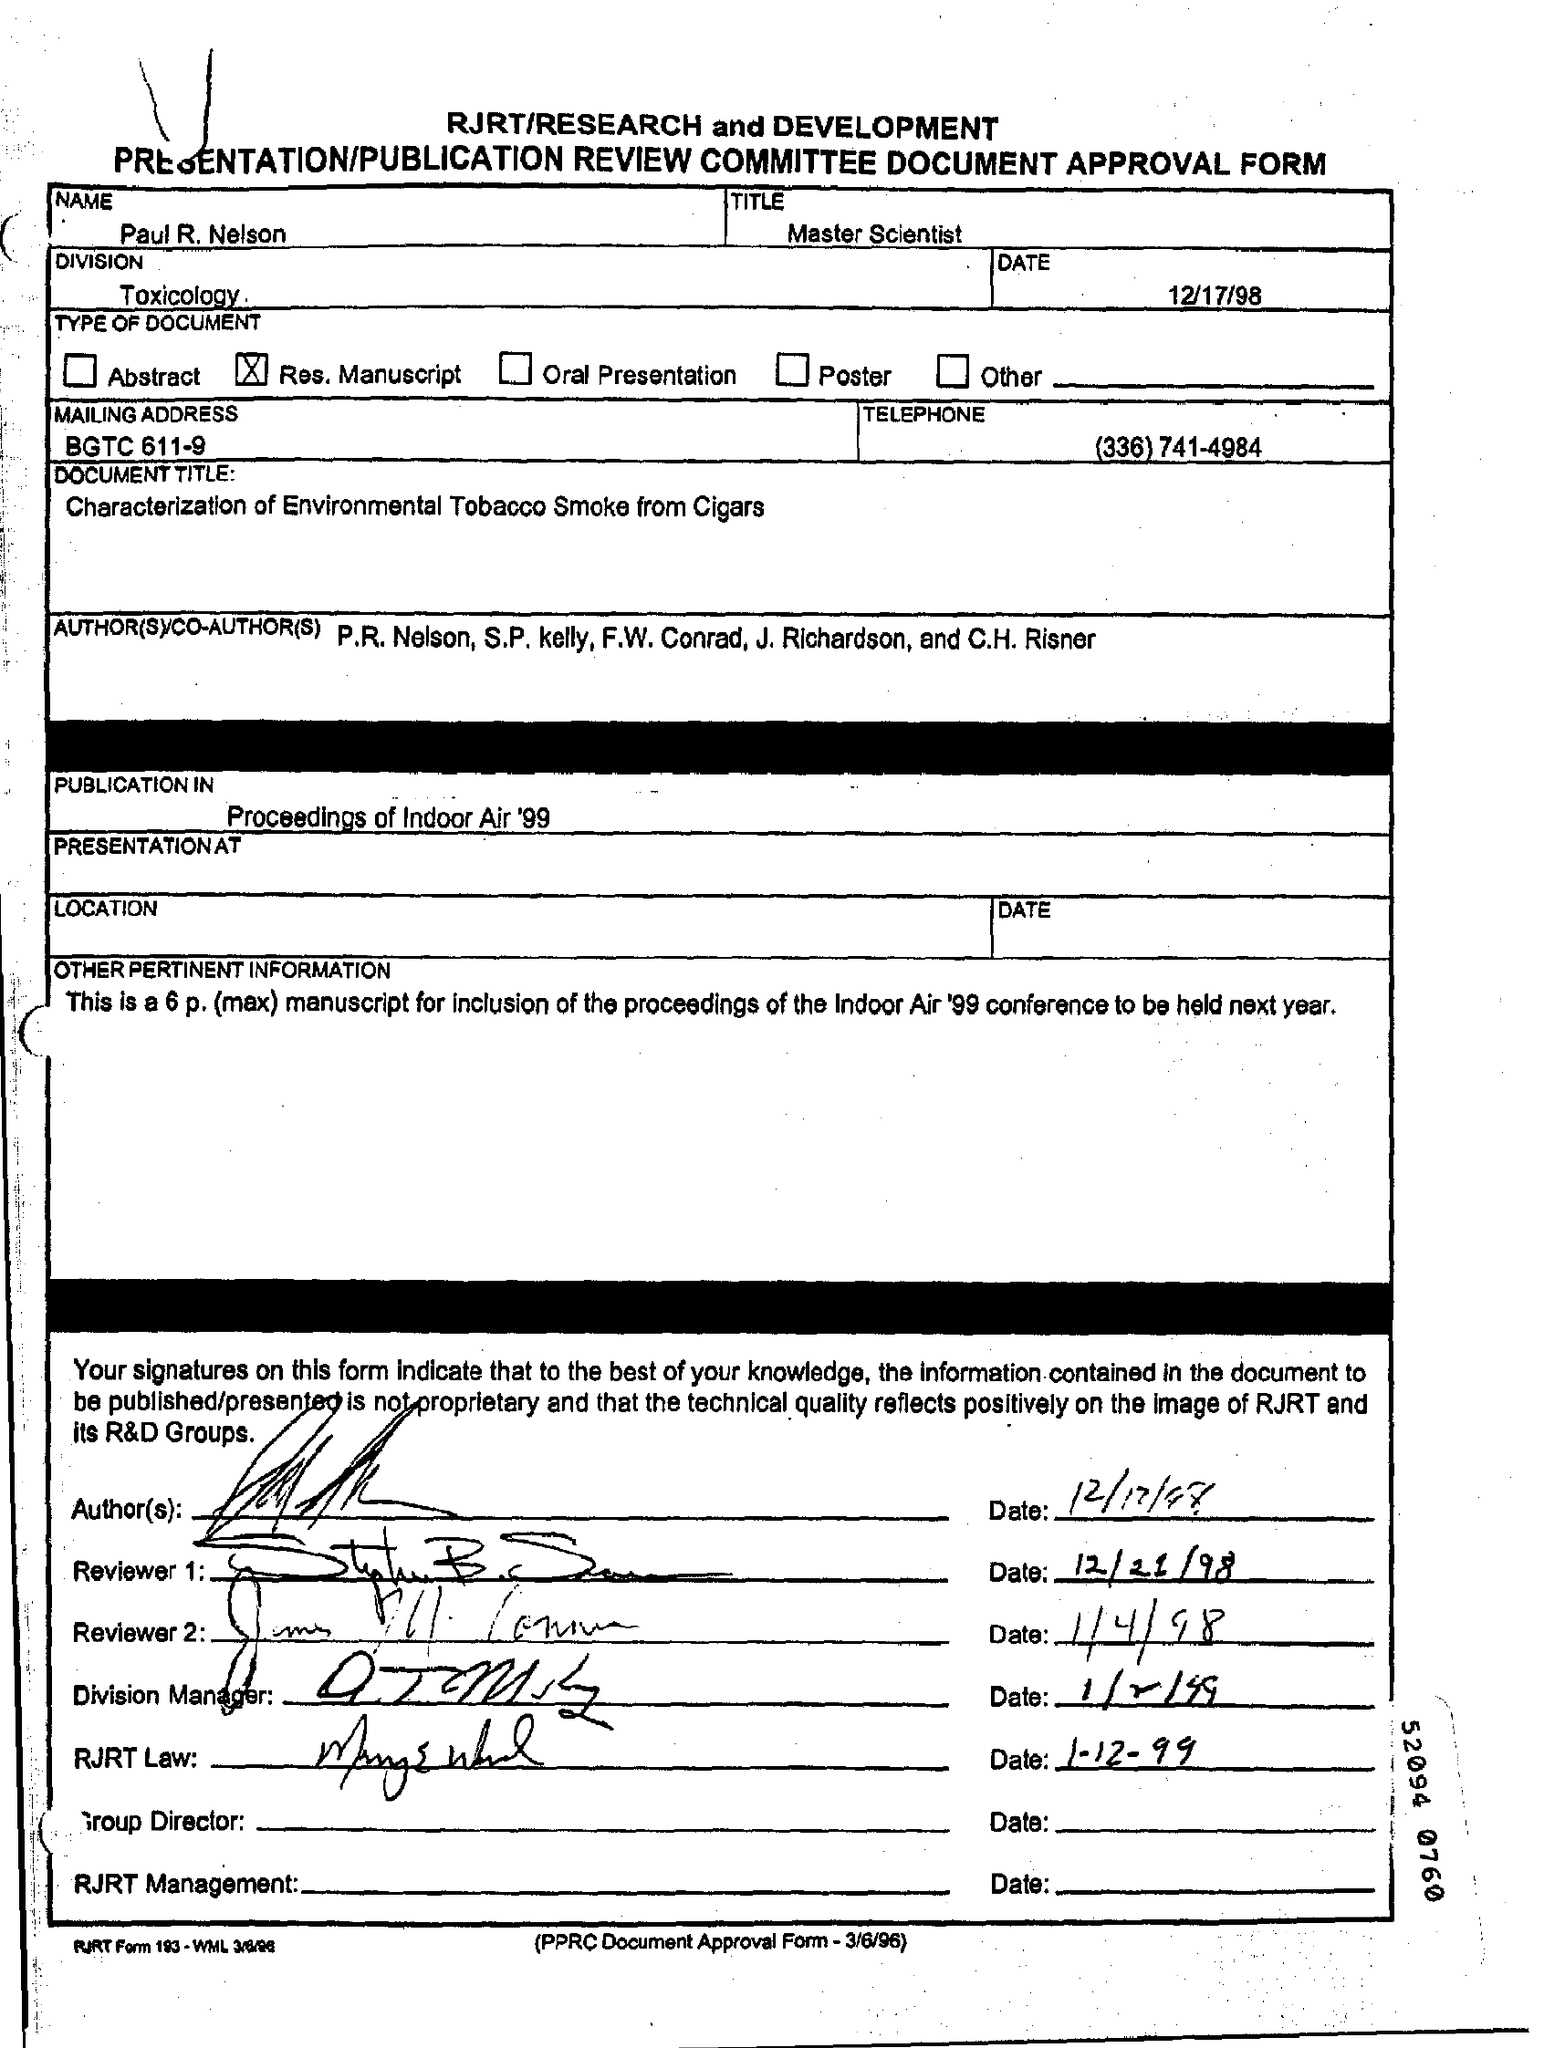What is the name given?
Offer a terse response. PAUL R. NELSON. What is the designation of Paul?
Your answer should be compact. Master Scientist. Which division is mentioned?
Your answer should be very brief. Toxicology. When is the document dated?
Offer a terse response. 12/17/98. What is the document title?
Make the answer very short. Characterization of Environmental Tobacco Smoke from Cigars. Where is the manuscript going to be published?
Provide a succinct answer. Proceedings of Indoor Air '99. 